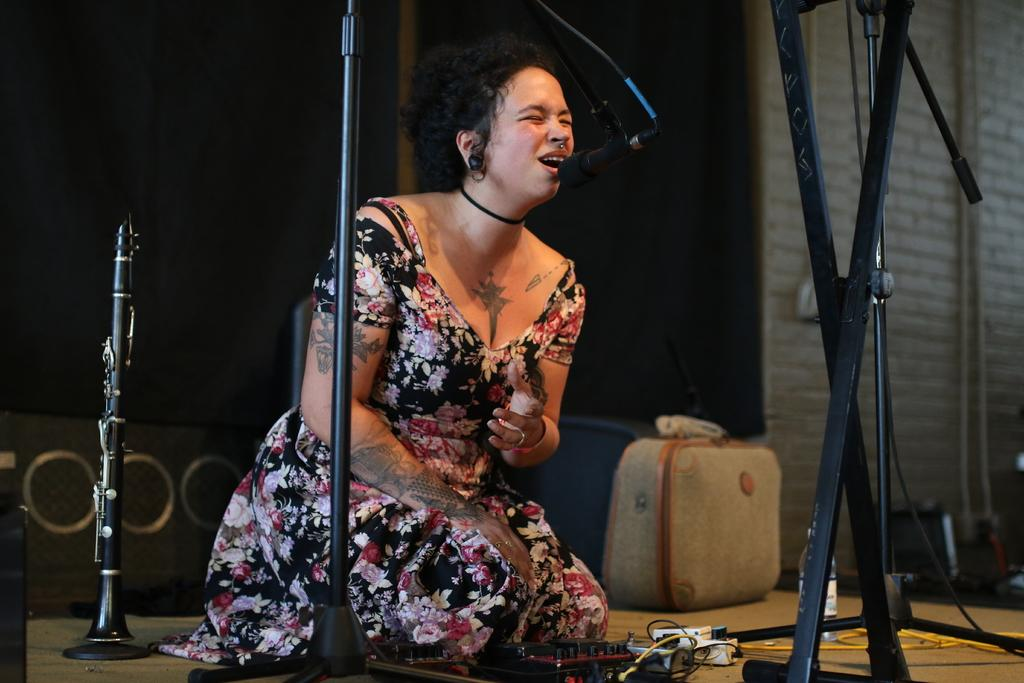Who is the main subject in the image? There is a woman in the image. Where is the woman located? The woman is sitting on a stage. What is the woman doing in the image? The woman is singing in front of a microphone and a stand. What else can be seen beside the woman? There is a musical instrument beside the woman. What is visible in the background of the image? There is a box and a wall in the background of the image. What type of meal is being prepared on stage by the woman? There is no meal being prepared in the image; the woman is singing with a microphone and a stand. 